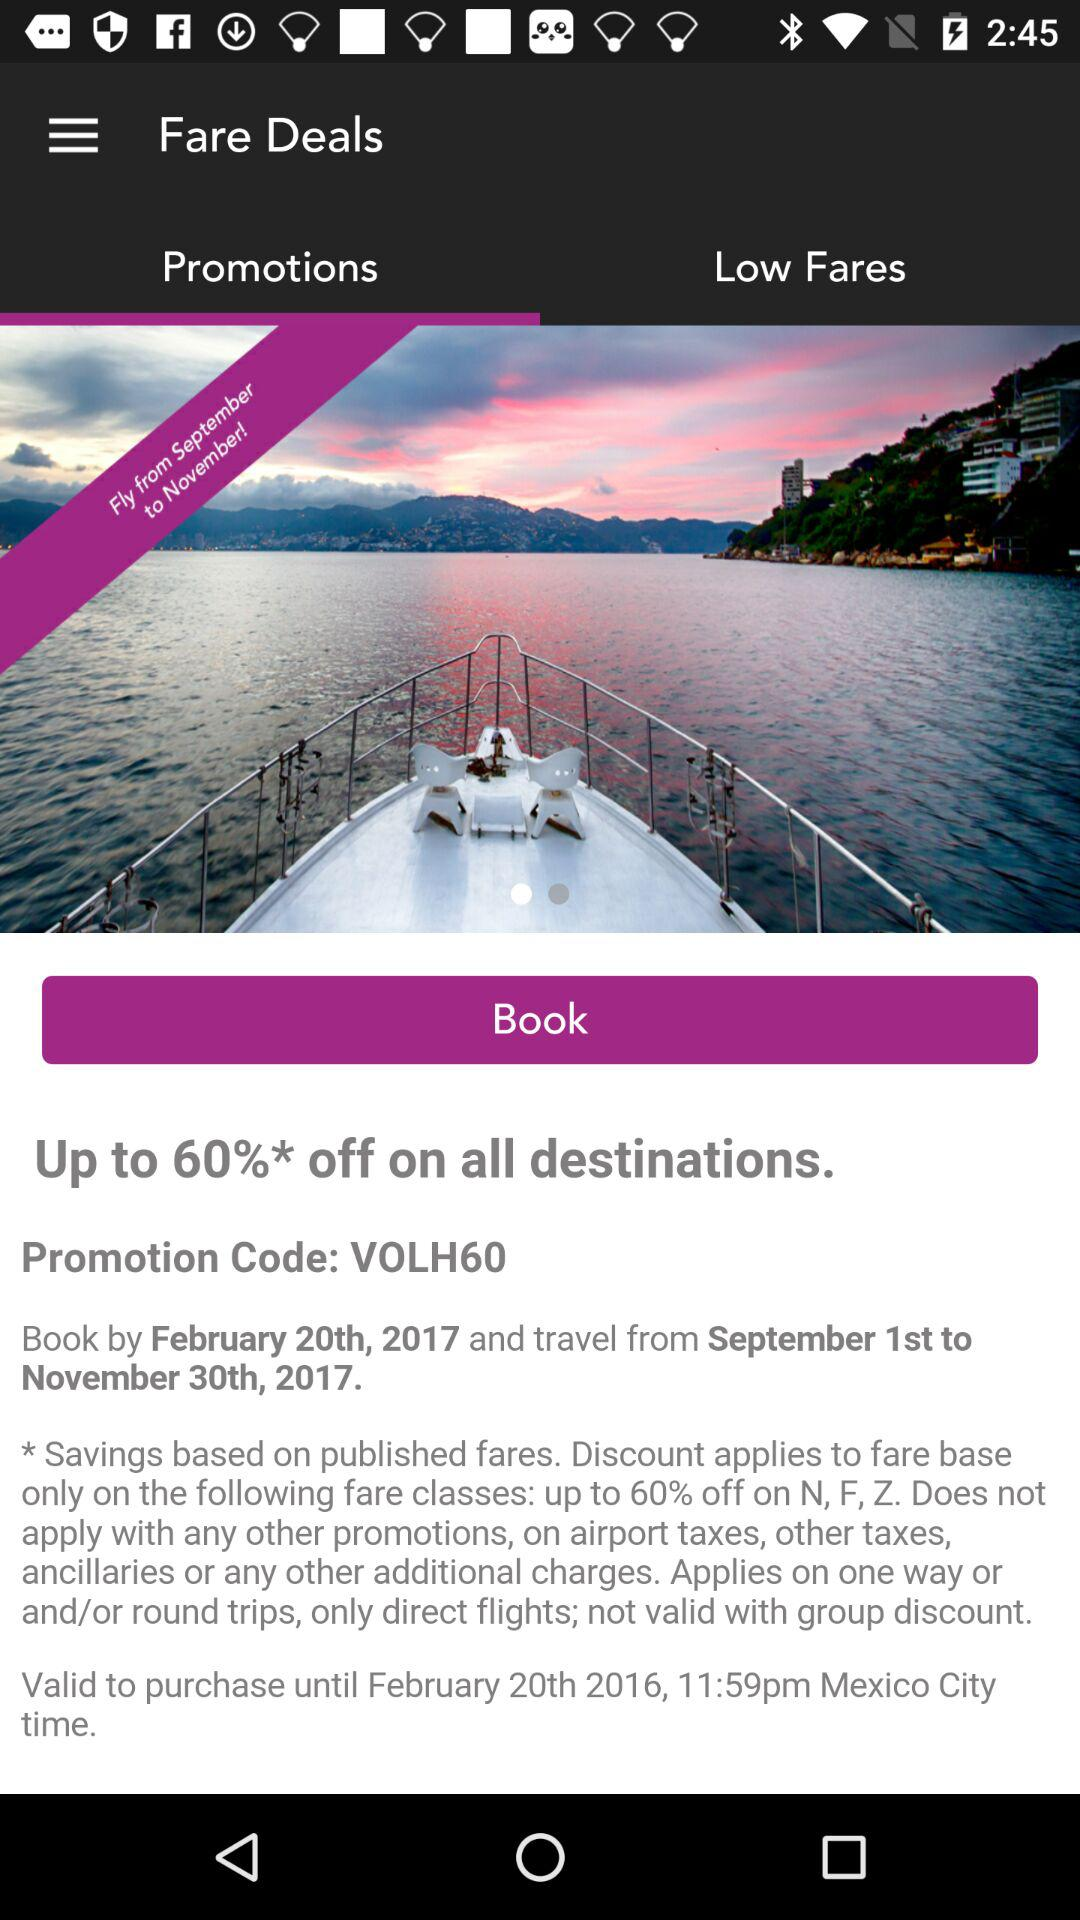What is the discount percentage? The discount percentage is up to 60%. 